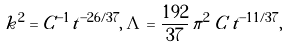<formula> <loc_0><loc_0><loc_500><loc_500>k ^ { 2 } = C ^ { - 1 } t ^ { - 2 6 / 3 7 } , \, \Lambda = \frac { 1 9 2 } { 3 7 } \, \pi ^ { 2 } \, C \, t ^ { - 1 1 / 3 7 } ,</formula> 